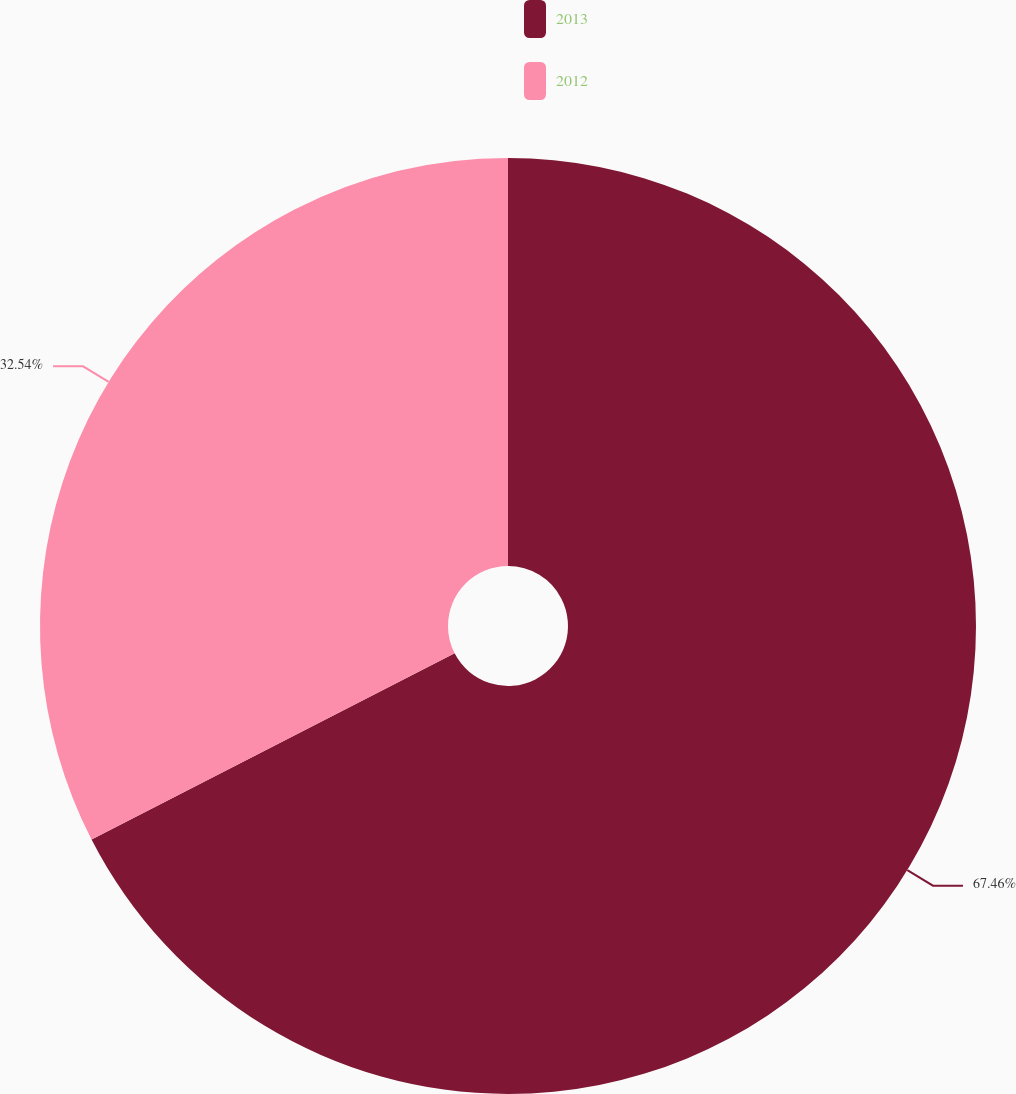Convert chart to OTSL. <chart><loc_0><loc_0><loc_500><loc_500><pie_chart><fcel>2013<fcel>2012<nl><fcel>67.46%<fcel>32.54%<nl></chart> 